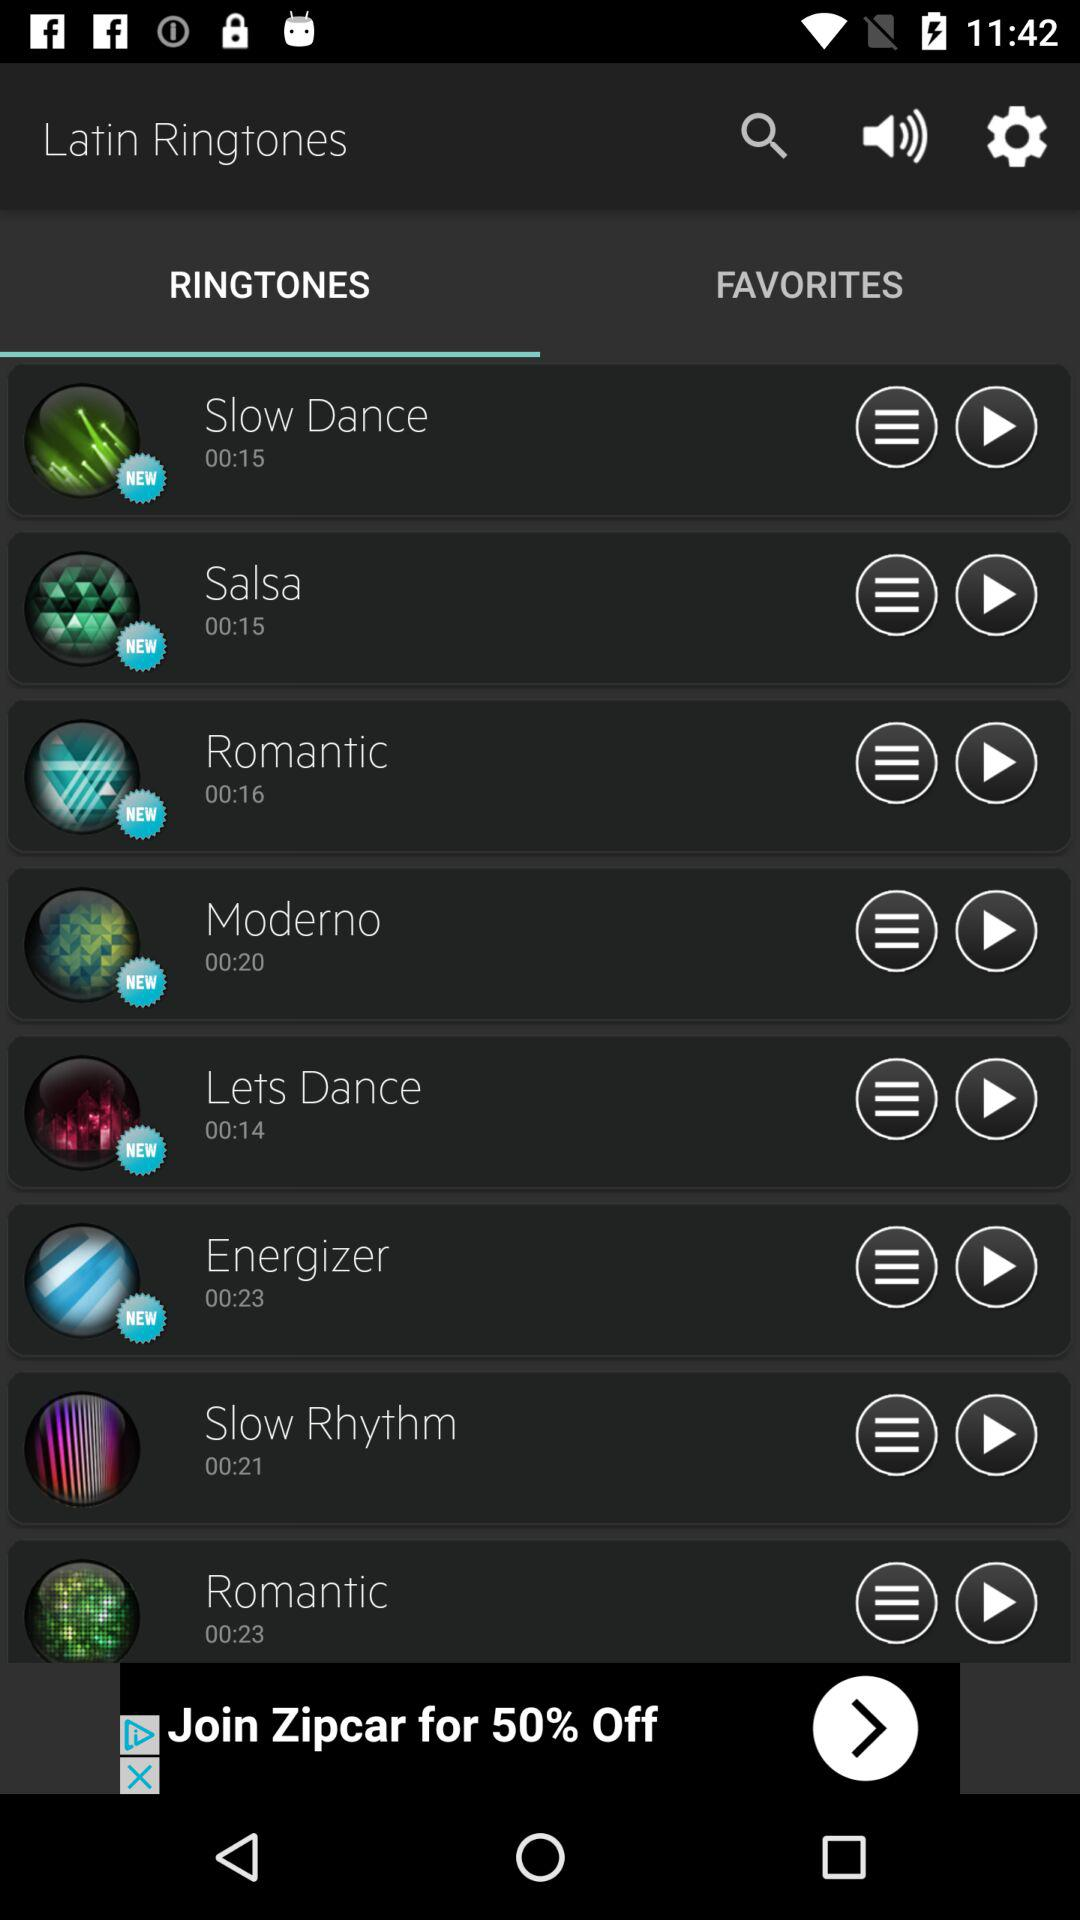Which are the favorite ringtones?
When the provided information is insufficient, respond with <no answer>. <no answer> 